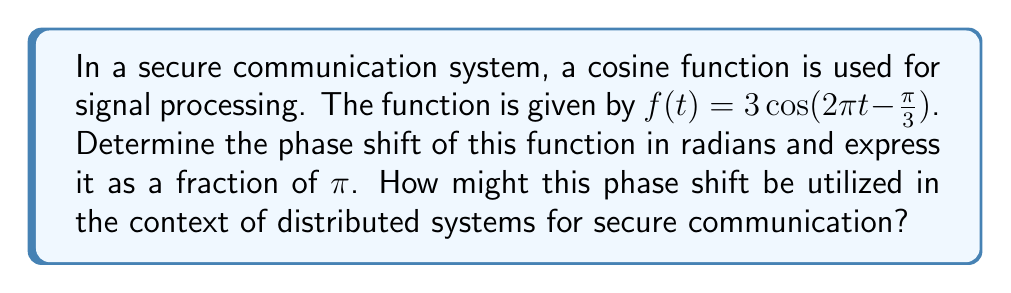Teach me how to tackle this problem. To solve this problem, let's break it down into steps:

1) The general form of a cosine function is:

   $f(t) = A\cos(B(t - C)) + D$

   where $A$ is the amplitude, $B$ is the angular frequency, $C$ is the phase shift, and $D$ is the vertical shift.

2) Our function is:

   $f(t) = 3\cos(2\pi t - \frac{\pi}{3})$

3) To match the general form, we need to rewrite it as:

   $f(t) = 3\cos(2\pi(t - \frac{1}{6}))$

4) We can see that:
   $A = 3$
   $B = 2\pi$
   $C = \frac{1}{6}$
   $D = 0$

5) The phase shift is $C = \frac{1}{6}$

6) To express this as a fraction of $\pi$, we multiply by $\pi$:

   $\frac{1}{6} \pi = \frac{\pi}{6}$

In the context of distributed systems and secure communication:

- Phase shifts can be used in signal modulation techniques like Phase Shift Keying (PSK).
- In distributed systems, synchronized clocks are crucial. The phase shift could represent a time offset between nodes.
- For cryptography, the phase shift could be part of a key or a parameter in a cryptographic algorithm.
- In secure multiparty computation, phase shifts could be used to encode information in a way that's resistant to eavesdropping.
Answer: The phase shift is $\frac{\pi}{6}$ radians. 